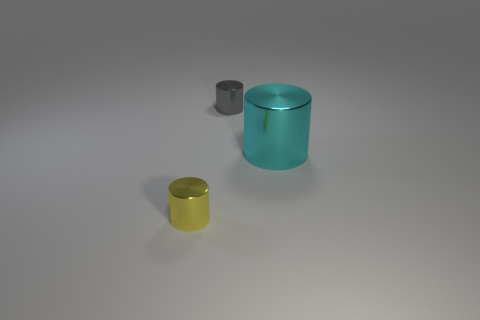Is there anything else that is the same size as the cyan cylinder?
Provide a succinct answer. No. How many gray metallic cylinders are there?
Provide a succinct answer. 1. Does the small gray object have the same material as the object to the left of the tiny gray metallic object?
Offer a terse response. Yes. What is the material of the thing that is both behind the small yellow metal thing and to the left of the big cylinder?
Keep it short and to the point. Metal. What is the size of the cyan thing?
Provide a short and direct response. Large. How many other objects are there of the same color as the big object?
Keep it short and to the point. 0. There is a metallic cylinder left of the small gray thing; does it have the same size as the gray shiny thing on the left side of the cyan thing?
Provide a short and direct response. Yes. There is a tiny metallic cylinder that is on the right side of the small yellow shiny cylinder; what color is it?
Your answer should be compact. Gray. Is the number of small metallic things behind the large object less than the number of small shiny cylinders?
Your response must be concise. Yes. Is the material of the big object the same as the small yellow cylinder?
Ensure brevity in your answer.  Yes. 